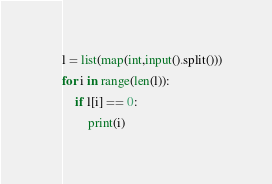Convert code to text. <code><loc_0><loc_0><loc_500><loc_500><_Python_>l = list(map(int,input().split()))
for i in range(len(l)):
	if l[i] == 0:
		print(i)
</code> 